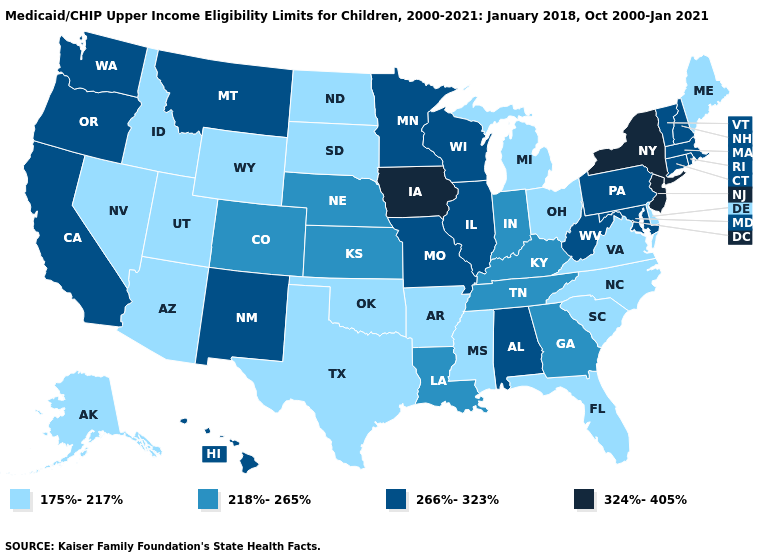What is the highest value in states that border Oregon?
Short answer required. 266%-323%. What is the value of Pennsylvania?
Quick response, please. 266%-323%. Does Kentucky have the highest value in the USA?
Be succinct. No. Name the states that have a value in the range 266%-323%?
Short answer required. Alabama, California, Connecticut, Hawaii, Illinois, Maryland, Massachusetts, Minnesota, Missouri, Montana, New Hampshire, New Mexico, Oregon, Pennsylvania, Rhode Island, Vermont, Washington, West Virginia, Wisconsin. Name the states that have a value in the range 266%-323%?
Concise answer only. Alabama, California, Connecticut, Hawaii, Illinois, Maryland, Massachusetts, Minnesota, Missouri, Montana, New Hampshire, New Mexico, Oregon, Pennsylvania, Rhode Island, Vermont, Washington, West Virginia, Wisconsin. Among the states that border Utah , which have the lowest value?
Write a very short answer. Arizona, Idaho, Nevada, Wyoming. Name the states that have a value in the range 266%-323%?
Write a very short answer. Alabama, California, Connecticut, Hawaii, Illinois, Maryland, Massachusetts, Minnesota, Missouri, Montana, New Hampshire, New Mexico, Oregon, Pennsylvania, Rhode Island, Vermont, Washington, West Virginia, Wisconsin. What is the value of Nebraska?
Keep it brief. 218%-265%. Is the legend a continuous bar?
Quick response, please. No. Does South Carolina have the lowest value in the USA?
Quick response, please. Yes. Name the states that have a value in the range 218%-265%?
Be succinct. Colorado, Georgia, Indiana, Kansas, Kentucky, Louisiana, Nebraska, Tennessee. Name the states that have a value in the range 266%-323%?
Write a very short answer. Alabama, California, Connecticut, Hawaii, Illinois, Maryland, Massachusetts, Minnesota, Missouri, Montana, New Hampshire, New Mexico, Oregon, Pennsylvania, Rhode Island, Vermont, Washington, West Virginia, Wisconsin. What is the value of Vermont?
Concise answer only. 266%-323%. Which states have the lowest value in the South?
Be succinct. Arkansas, Delaware, Florida, Mississippi, North Carolina, Oklahoma, South Carolina, Texas, Virginia. Name the states that have a value in the range 218%-265%?
Give a very brief answer. Colorado, Georgia, Indiana, Kansas, Kentucky, Louisiana, Nebraska, Tennessee. 